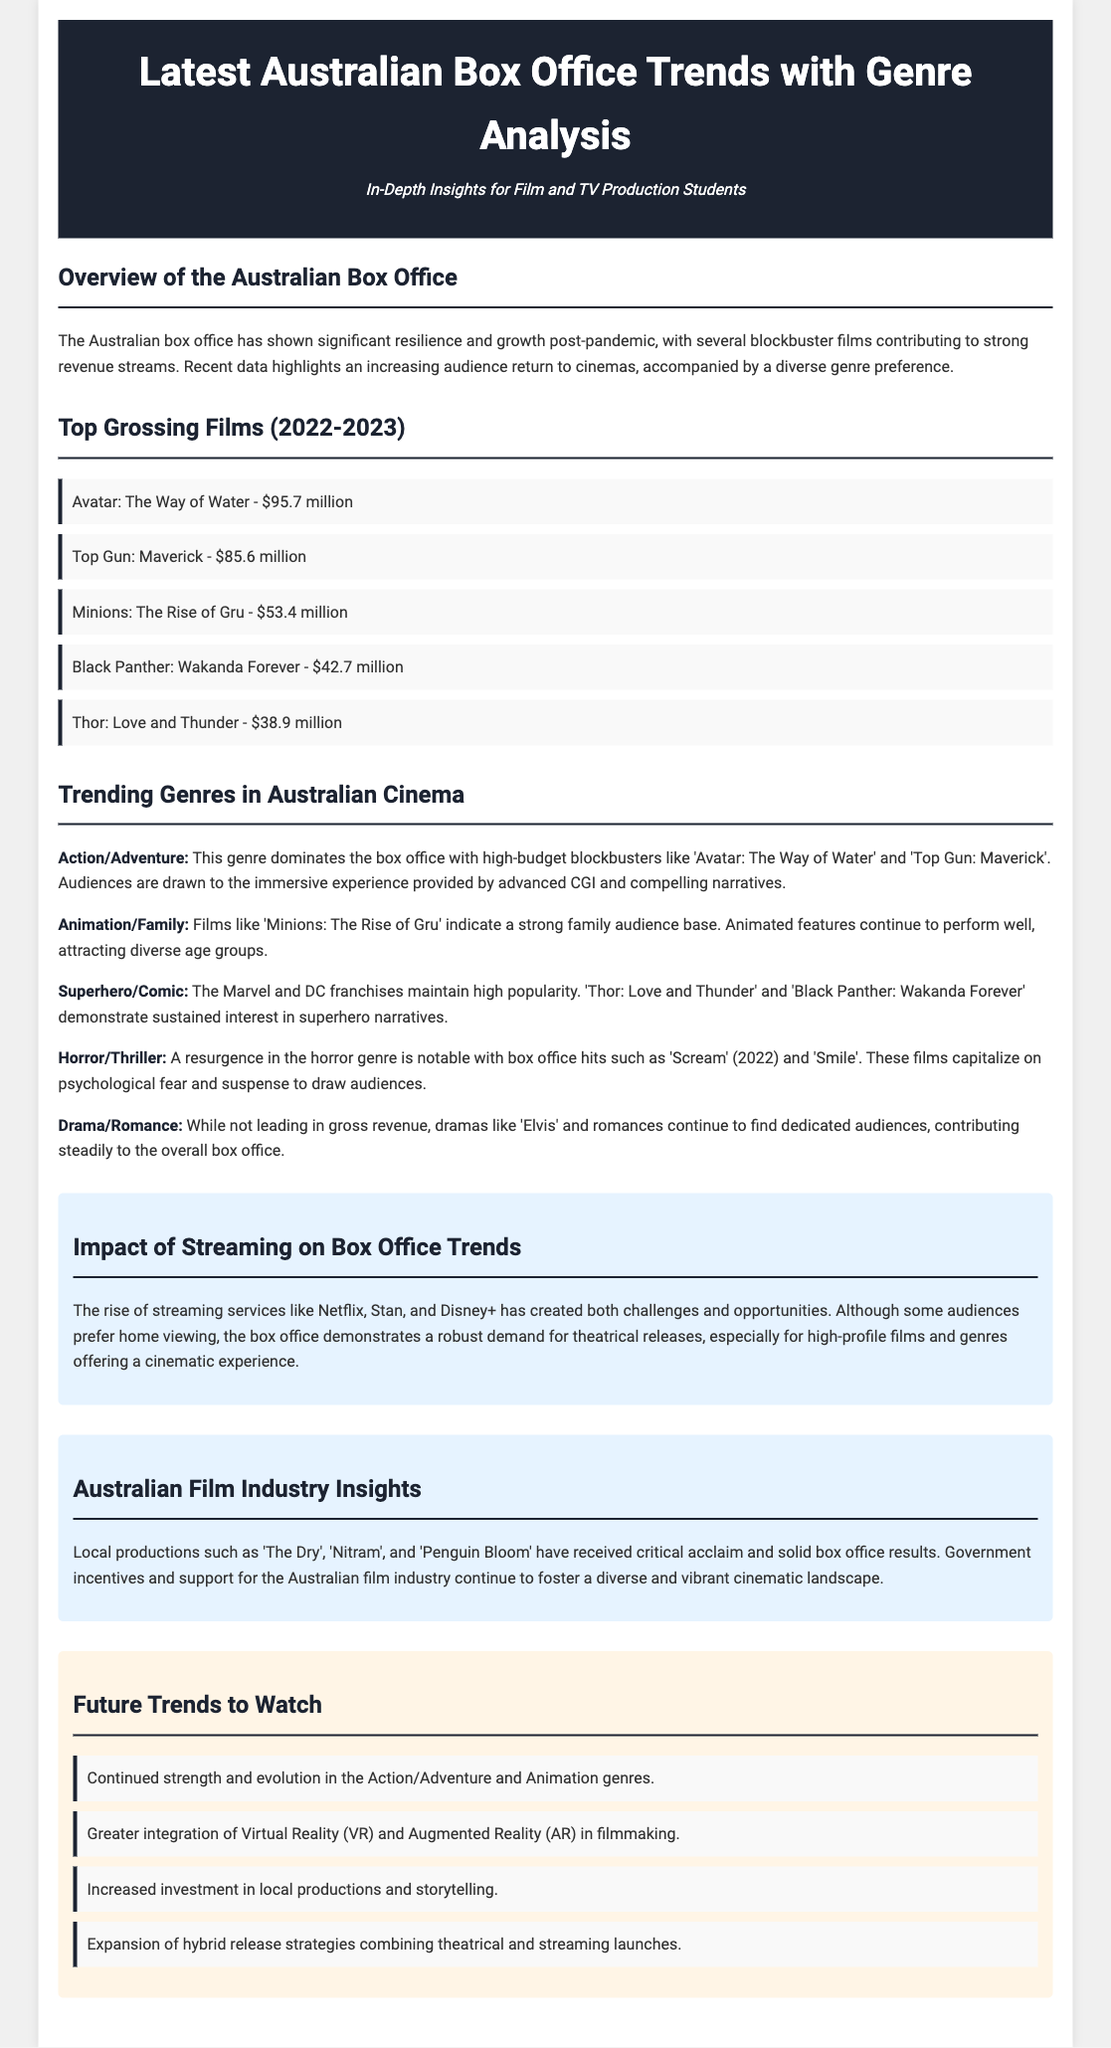what was the highest-grossing film in 2023? The film with the highest revenue in 2023 is "Avatar: The Way of Water," which earned $95.7 million.
Answer: Avatar: The Way of Water what genre shows notable growth, particularly in the 2022-2023 box office? The Action/Adventure genre demonstrates significant growth, with blockbuster titles attracting large audiences.
Answer: Action/Adventure how much did "Top Gun: Maverick" gross? "Top Gun: Maverick" grossed $85.6 million, making it one of the top-grossing films.
Answer: $85.6 million which genre has a resurgence according to the document? The Horror/Thriller genre has seen a resurgence with box office hits like "Scream" and "Smile".
Answer: Horror/Thriller what films are mentioned as critically acclaimed local productions? "The Dry," "Nitram," and "Penguin Bloom" are mentioned as successful local productions in Australia.
Answer: The Dry, Nitram, Penguin Bloom what is the impact of streaming services on box office trends? Streaming services present challenges but the document indicates strong demand for theatrical releases still exists.
Answer: Challenges and opportunities which genre contributes steadily to the overall box office? The Drama/Romance genre contributes steadily, despite not leading in gross revenue.
Answer: Drama/Romance what future trend involves using technology in filmmaking? Greater integration of Virtual Reality (VR) and Augmented Reality (AR) in filmmaking is a notable future trend.
Answer: VR and AR what is the subtitle of the document? The subtitle provides context for the audience and states it is for film and TV production students.
Answer: In-Depth Insights for Film and TV Production Students 